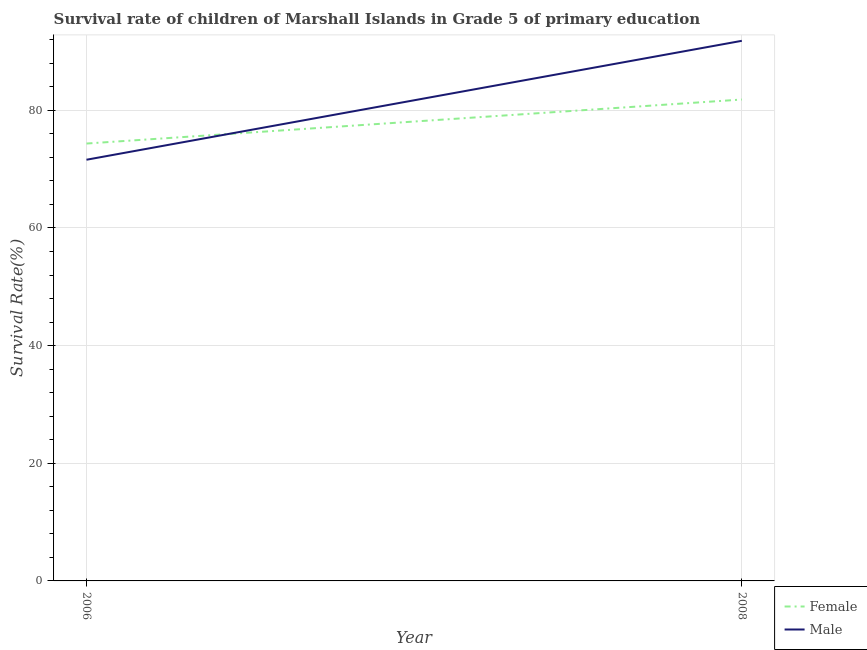Does the line corresponding to survival rate of female students in primary education intersect with the line corresponding to survival rate of male students in primary education?
Give a very brief answer. Yes. Is the number of lines equal to the number of legend labels?
Give a very brief answer. Yes. What is the survival rate of female students in primary education in 2006?
Give a very brief answer. 74.36. Across all years, what is the maximum survival rate of male students in primary education?
Provide a succinct answer. 91.82. Across all years, what is the minimum survival rate of male students in primary education?
Your answer should be very brief. 71.6. In which year was the survival rate of male students in primary education minimum?
Your answer should be compact. 2006. What is the total survival rate of female students in primary education in the graph?
Keep it short and to the point. 156.19. What is the difference between the survival rate of male students in primary education in 2006 and that in 2008?
Your response must be concise. -20.22. What is the difference between the survival rate of female students in primary education in 2006 and the survival rate of male students in primary education in 2008?
Give a very brief answer. -17.46. What is the average survival rate of male students in primary education per year?
Provide a succinct answer. 81.71. In the year 2006, what is the difference between the survival rate of female students in primary education and survival rate of male students in primary education?
Offer a very short reply. 2.75. In how many years, is the survival rate of female students in primary education greater than 36 %?
Offer a very short reply. 2. What is the ratio of the survival rate of male students in primary education in 2006 to that in 2008?
Keep it short and to the point. 0.78. Is the survival rate of male students in primary education in 2006 less than that in 2008?
Make the answer very short. Yes. Is the survival rate of female students in primary education strictly greater than the survival rate of male students in primary education over the years?
Your response must be concise. No. Is the survival rate of female students in primary education strictly less than the survival rate of male students in primary education over the years?
Ensure brevity in your answer.  No. How many years are there in the graph?
Give a very brief answer. 2. Are the values on the major ticks of Y-axis written in scientific E-notation?
Offer a very short reply. No. Does the graph contain any zero values?
Offer a very short reply. No. Does the graph contain grids?
Your answer should be compact. Yes. What is the title of the graph?
Offer a very short reply. Survival rate of children of Marshall Islands in Grade 5 of primary education. Does "Total Population" appear as one of the legend labels in the graph?
Make the answer very short. No. What is the label or title of the X-axis?
Your response must be concise. Year. What is the label or title of the Y-axis?
Make the answer very short. Survival Rate(%). What is the Survival Rate(%) in Female in 2006?
Give a very brief answer. 74.36. What is the Survival Rate(%) of Male in 2006?
Offer a terse response. 71.6. What is the Survival Rate(%) of Female in 2008?
Your answer should be very brief. 81.84. What is the Survival Rate(%) in Male in 2008?
Keep it short and to the point. 91.82. Across all years, what is the maximum Survival Rate(%) of Female?
Provide a succinct answer. 81.84. Across all years, what is the maximum Survival Rate(%) of Male?
Your response must be concise. 91.82. Across all years, what is the minimum Survival Rate(%) of Female?
Make the answer very short. 74.36. Across all years, what is the minimum Survival Rate(%) in Male?
Keep it short and to the point. 71.6. What is the total Survival Rate(%) of Female in the graph?
Offer a terse response. 156.19. What is the total Survival Rate(%) of Male in the graph?
Offer a terse response. 163.42. What is the difference between the Survival Rate(%) of Female in 2006 and that in 2008?
Your response must be concise. -7.48. What is the difference between the Survival Rate(%) of Male in 2006 and that in 2008?
Give a very brief answer. -20.22. What is the difference between the Survival Rate(%) of Female in 2006 and the Survival Rate(%) of Male in 2008?
Ensure brevity in your answer.  -17.46. What is the average Survival Rate(%) of Female per year?
Offer a terse response. 78.1. What is the average Survival Rate(%) of Male per year?
Offer a very short reply. 81.71. In the year 2006, what is the difference between the Survival Rate(%) in Female and Survival Rate(%) in Male?
Offer a very short reply. 2.75. In the year 2008, what is the difference between the Survival Rate(%) in Female and Survival Rate(%) in Male?
Provide a short and direct response. -9.98. What is the ratio of the Survival Rate(%) in Female in 2006 to that in 2008?
Make the answer very short. 0.91. What is the ratio of the Survival Rate(%) of Male in 2006 to that in 2008?
Offer a very short reply. 0.78. What is the difference between the highest and the second highest Survival Rate(%) of Female?
Give a very brief answer. 7.48. What is the difference between the highest and the second highest Survival Rate(%) in Male?
Keep it short and to the point. 20.22. What is the difference between the highest and the lowest Survival Rate(%) in Female?
Make the answer very short. 7.48. What is the difference between the highest and the lowest Survival Rate(%) of Male?
Ensure brevity in your answer.  20.22. 